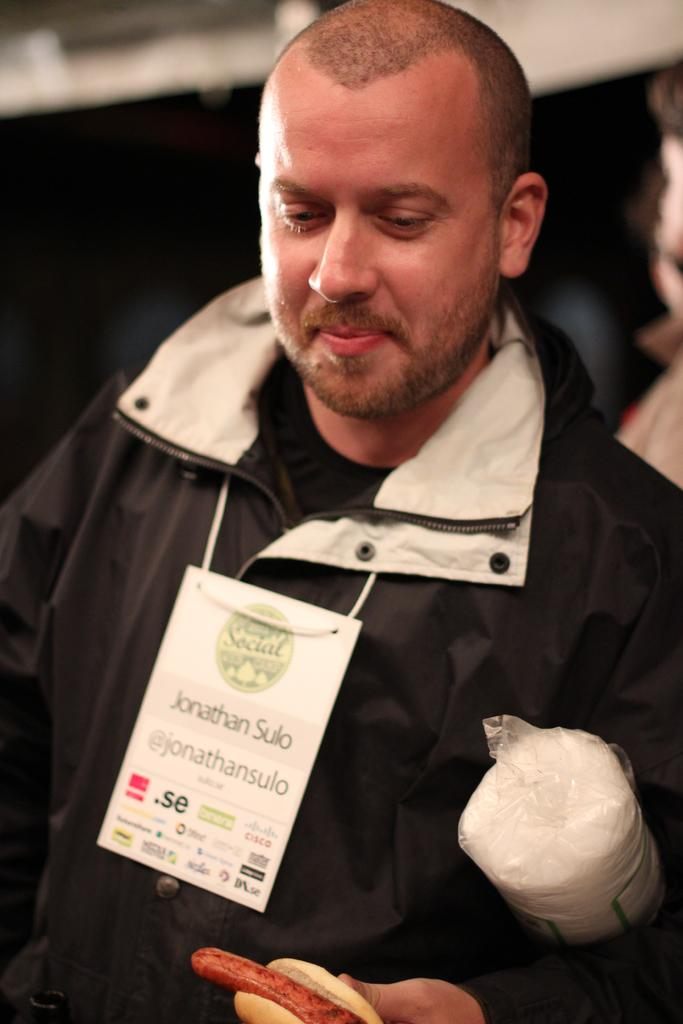What is the main subject of the image? There is a man standing in the image. Can you describe the man's clothing? The man is wearing a black jacket. What is the man holding in his hand? The man is holding something in his hand, but the specific object cannot be identified from the image. How would you describe the background of the image? The background of the image is blurred. What type of leaf can be seen falling in the image? There is no leaf present in the image; it features a man standing with a blurred background. 